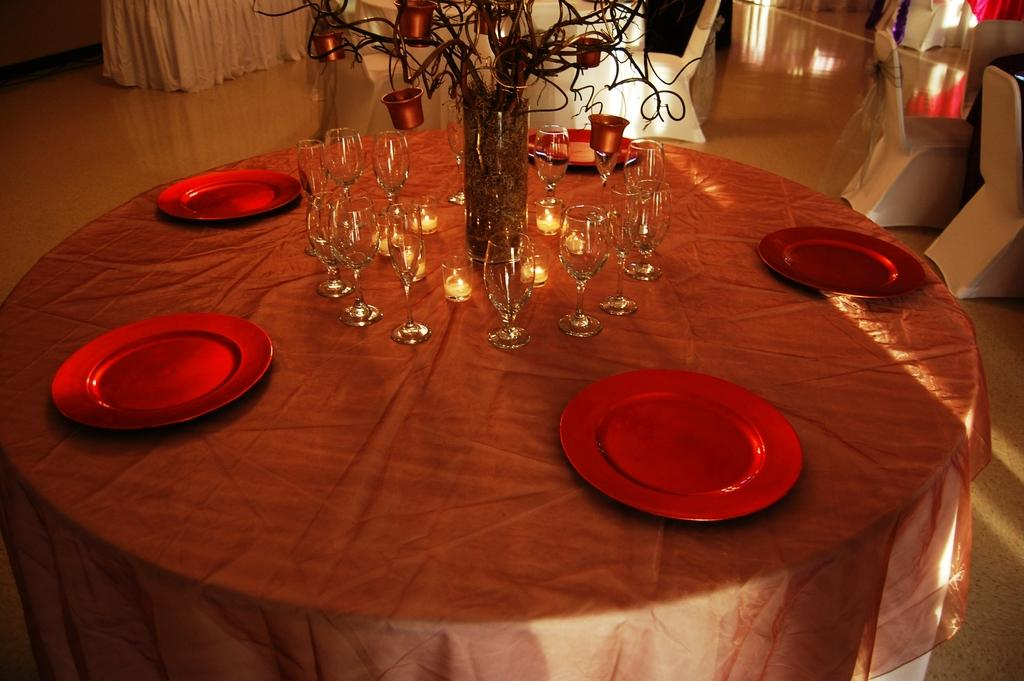What type of furniture is present in the image? There is a table in the image. What is covering the table? The table has a cloth covering it. How are the plates arranged on the table? The red plates are arranged in a circle on the table. What type of glasses are on the table? There are wine glasses on the table. What type of cemetery can be seen in the background of the image? There is no cemetery present in the image; it only features a table with a cloth, red plates arranged in a circle, and wine glasses. 